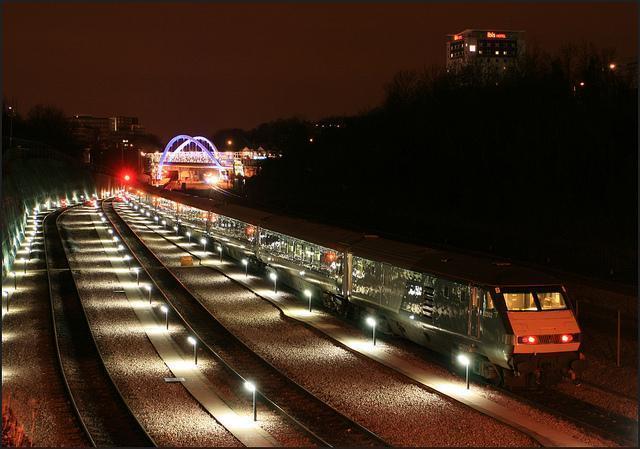How many colors are in the umbrella being held over the group's heads?
Give a very brief answer. 0. 